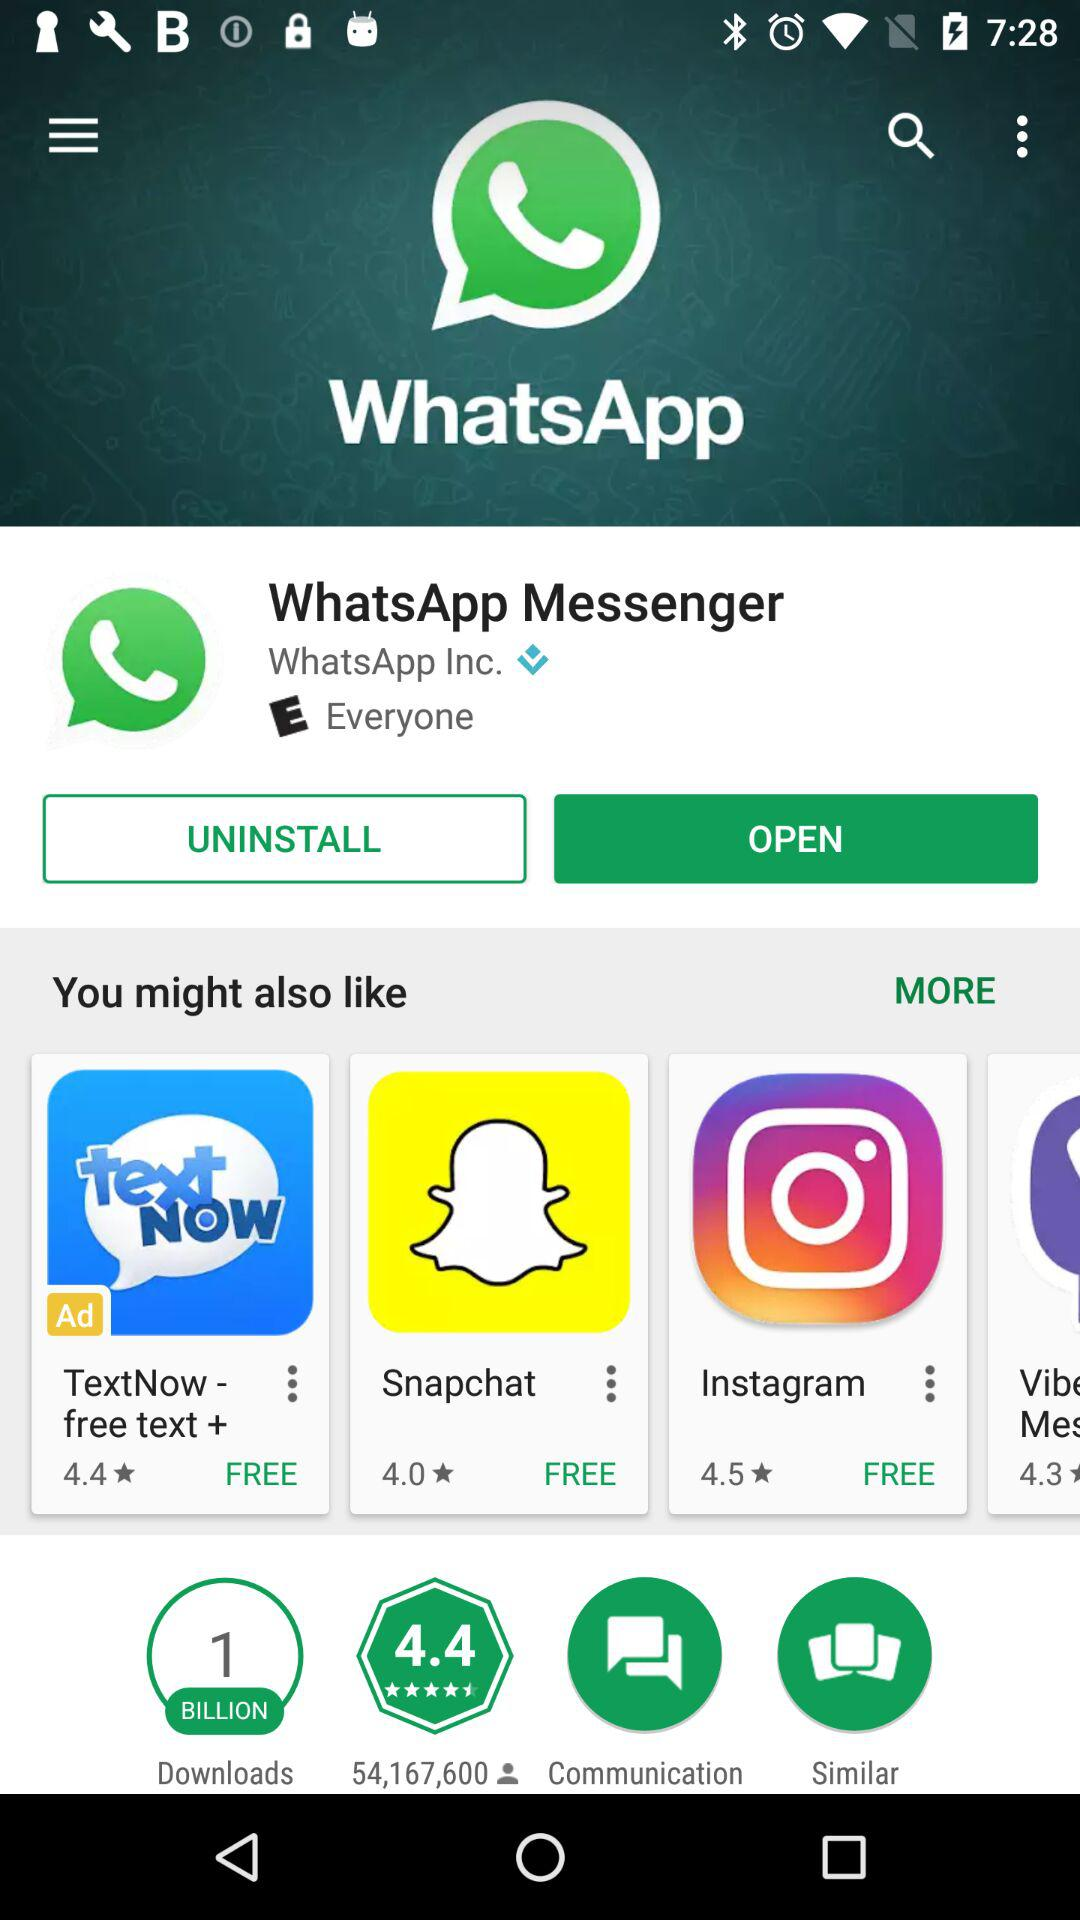What is the star rating of the application "Instagram"?
Answer the question using a single word or phrase. The rating is 4.5 stars 